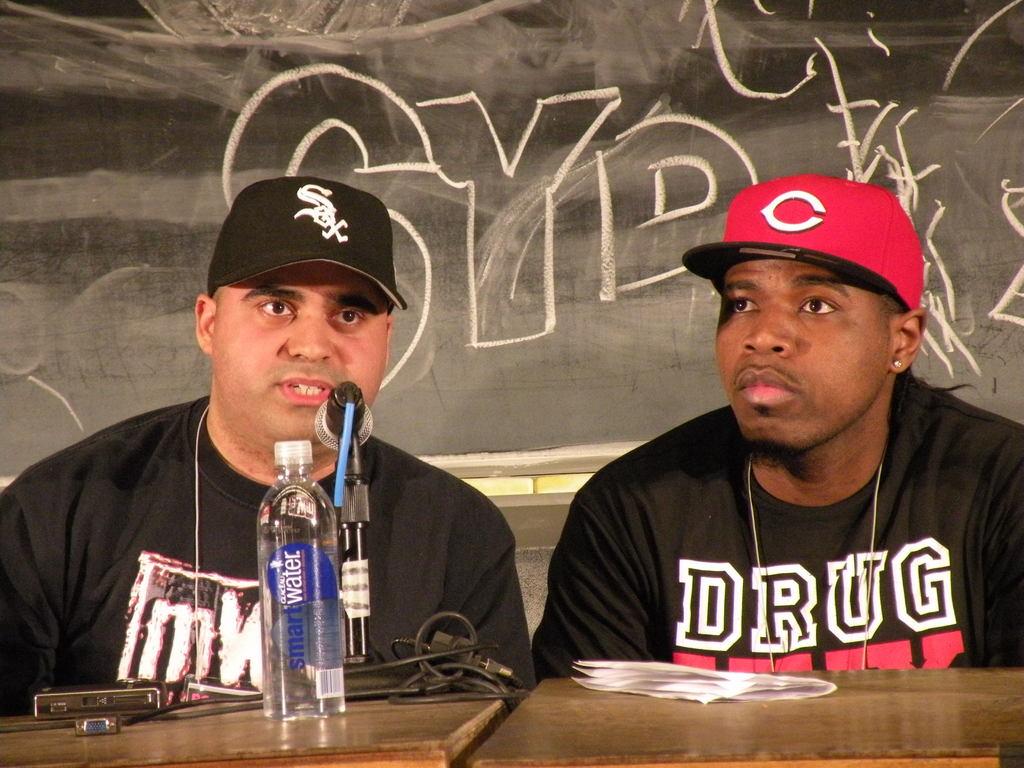What kind of water is on the table?
Give a very brief answer. Smart water. What letter is on the red hat?
Make the answer very short. C. 